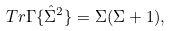Convert formula to latex. <formula><loc_0><loc_0><loc_500><loc_500>T r \Gamma \{ \hat { \Sigma } ^ { 2 } \} = \Sigma ( \Sigma + 1 ) ,</formula> 